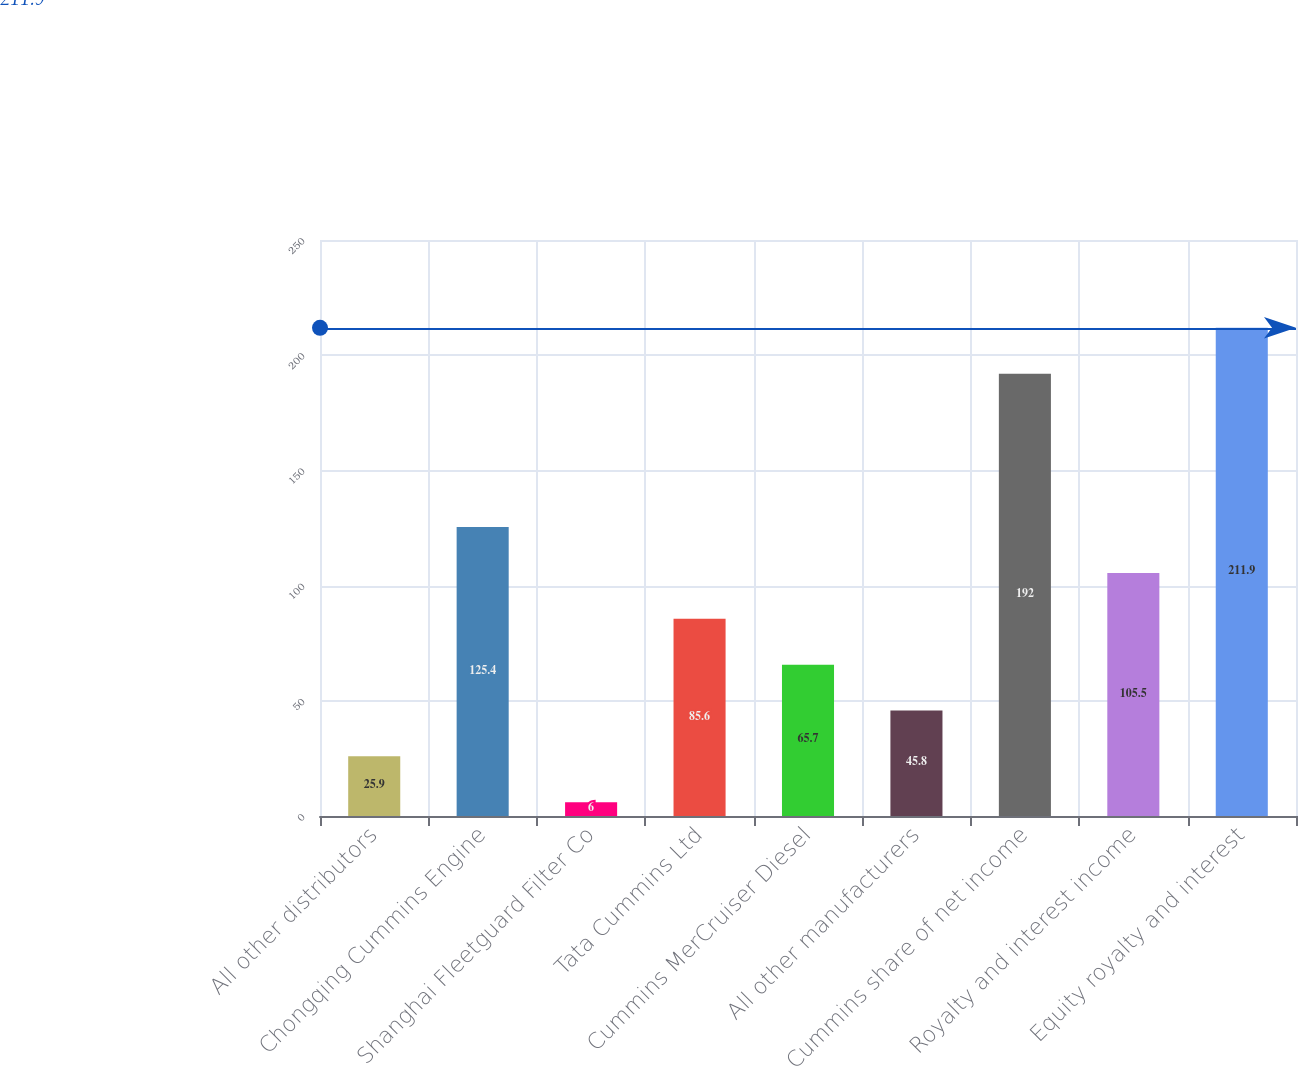Convert chart. <chart><loc_0><loc_0><loc_500><loc_500><bar_chart><fcel>All other distributors<fcel>Chongqing Cummins Engine<fcel>Shanghai Fleetguard Filter Co<fcel>Tata Cummins Ltd<fcel>Cummins MerCruiser Diesel<fcel>All other manufacturers<fcel>Cummins share of net income<fcel>Royalty and interest income<fcel>Equity royalty and interest<nl><fcel>25.9<fcel>125.4<fcel>6<fcel>85.6<fcel>65.7<fcel>45.8<fcel>192<fcel>105.5<fcel>211.9<nl></chart> 